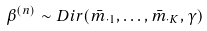Convert formula to latex. <formula><loc_0><loc_0><loc_500><loc_500>\beta ^ { ( n ) } \sim D i r ( \bar { m } _ { \cdot 1 } , \dots , \bar { m } _ { \cdot K } , \gamma )</formula> 